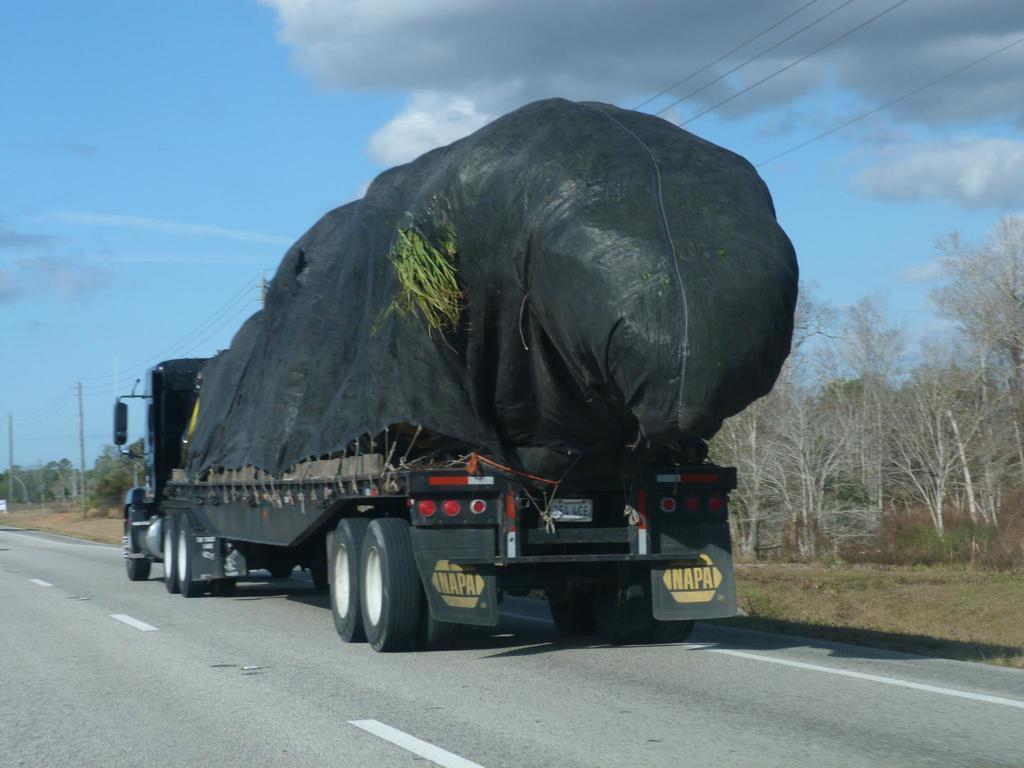In one or two sentences, can you explain what this image depicts? In this image, we can see a truck is on the road. Here we can see few white lines on the road. Background there are so many trees, poles, wires we can see. Here we can see a cloudy sky. 